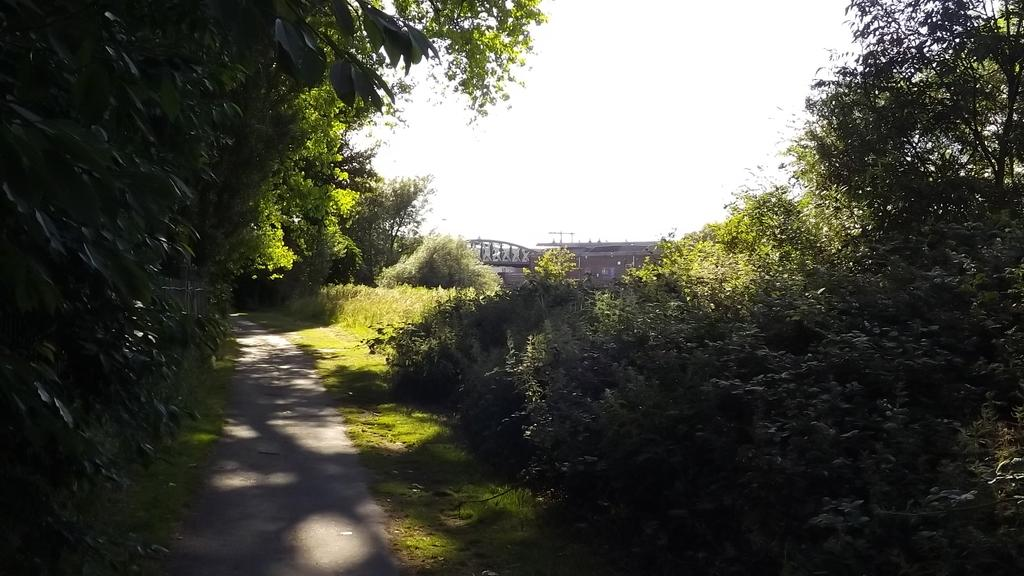What is the main feature of the image? There is a road in the image. What can be seen on the left side of the image? There are trees on the left side of the image. What can be seen on the right side of the image? There are trees and a bridge on the right side of the image. What type of vegetation is at the bottom of the image? There is green grass at the bottom of the image. What is visible at the top of the image? The sky is visible at the top of the image. What type of army is marching on the ground in the image? There is no army or ground present in the image; it features a road, trees, a bridge, green grass, and the sky. 